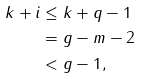<formula> <loc_0><loc_0><loc_500><loc_500>k + i & \leq k + q - 1 \\ & = g - m - 2 \\ & < g - 1 ,</formula> 